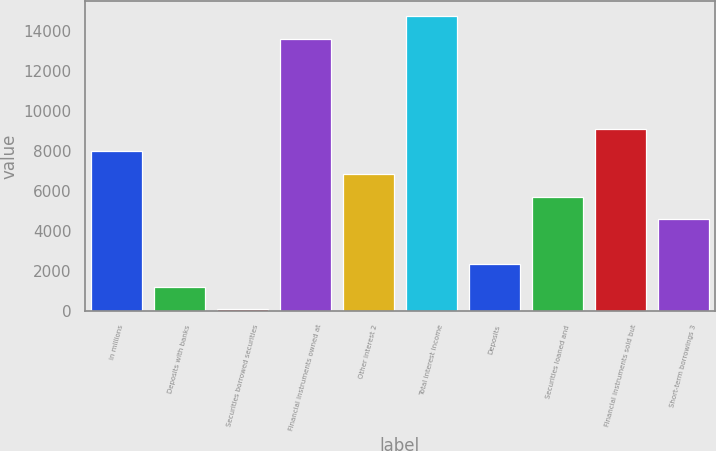<chart> <loc_0><loc_0><loc_500><loc_500><bar_chart><fcel>in millions<fcel>Deposits with banks<fcel>Securities borrowed securities<fcel>Financial instruments owned at<fcel>Other interest 2<fcel>Total interest income<fcel>Deposits<fcel>Securities loaned and<fcel>Financial instruments sold but<fcel>Short-term borrowings 3<nl><fcel>7989.8<fcel>1207.4<fcel>77<fcel>13641.8<fcel>6859.4<fcel>14772.2<fcel>2337.8<fcel>5729<fcel>9120.2<fcel>4598.6<nl></chart> 